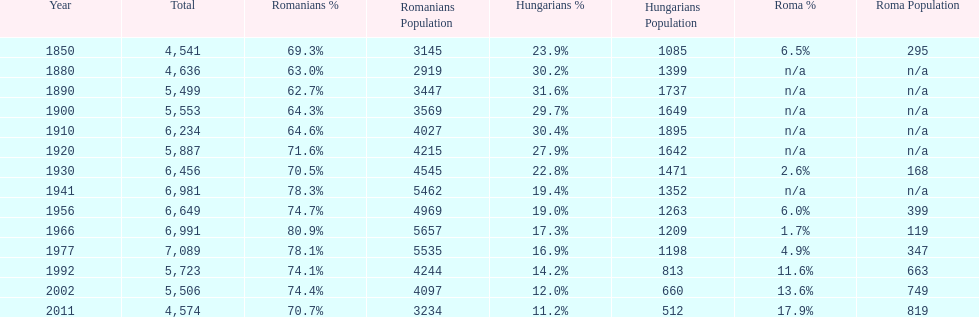What year had the next highest percentage for roma after 2011? 2002. 